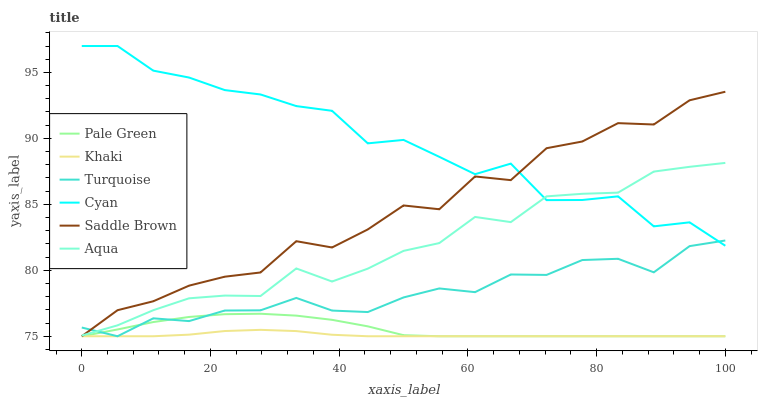Does Khaki have the minimum area under the curve?
Answer yes or no. Yes. Does Cyan have the maximum area under the curve?
Answer yes or no. Yes. Does Aqua have the minimum area under the curve?
Answer yes or no. No. Does Aqua have the maximum area under the curve?
Answer yes or no. No. Is Khaki the smoothest?
Answer yes or no. Yes. Is Cyan the roughest?
Answer yes or no. Yes. Is Aqua the smoothest?
Answer yes or no. No. Is Aqua the roughest?
Answer yes or no. No. Does Turquoise have the lowest value?
Answer yes or no. Yes. Does Aqua have the lowest value?
Answer yes or no. No. Does Cyan have the highest value?
Answer yes or no. Yes. Does Aqua have the highest value?
Answer yes or no. No. Is Pale Green less than Aqua?
Answer yes or no. Yes. Is Aqua greater than Khaki?
Answer yes or no. Yes. Does Aqua intersect Saddle Brown?
Answer yes or no. Yes. Is Aqua less than Saddle Brown?
Answer yes or no. No. Is Aqua greater than Saddle Brown?
Answer yes or no. No. Does Pale Green intersect Aqua?
Answer yes or no. No. 